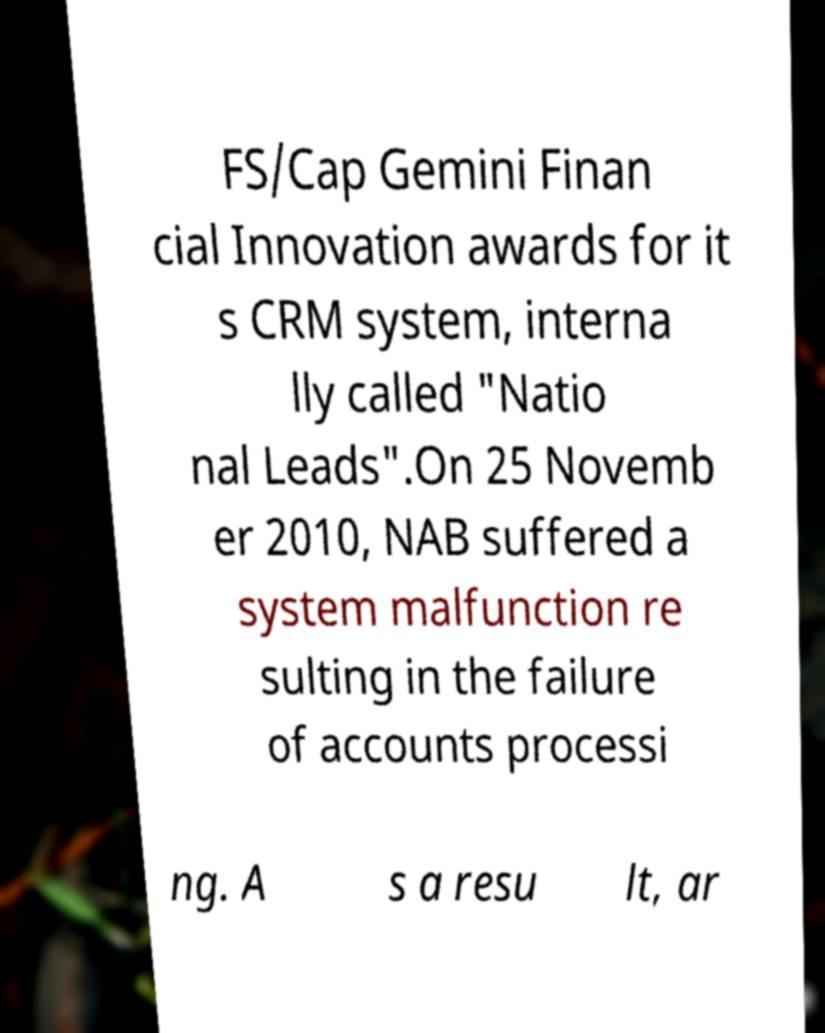Can you read and provide the text displayed in the image?This photo seems to have some interesting text. Can you extract and type it out for me? FS/Cap Gemini Finan cial Innovation awards for it s CRM system, interna lly called "Natio nal Leads".On 25 Novemb er 2010, NAB suffered a system malfunction re sulting in the failure of accounts processi ng. A s a resu lt, ar 